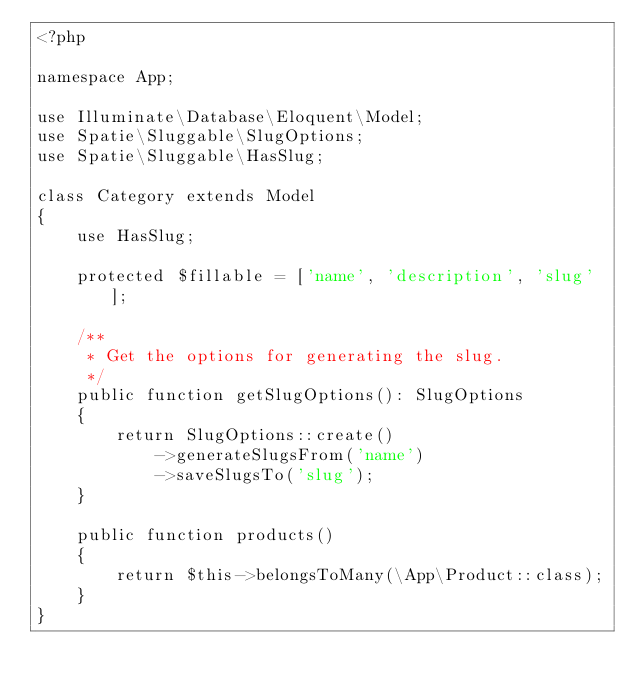Convert code to text. <code><loc_0><loc_0><loc_500><loc_500><_PHP_><?php

namespace App;

use Illuminate\Database\Eloquent\Model;
use Spatie\Sluggable\SlugOptions;
use Spatie\Sluggable\HasSlug;

class Category extends Model
{
    use HasSlug;

    protected $fillable = ['name', 'description', 'slug'];

    /**
     * Get the options for generating the slug.
     */
    public function getSlugOptions(): SlugOptions
    {
        return SlugOptions::create()
            ->generateSlugsFrom('name')
            ->saveSlugsTo('slug');
    }

    public function products()
    {
        return $this->belongsToMany(\App\Product::class);
    }
}
</code> 